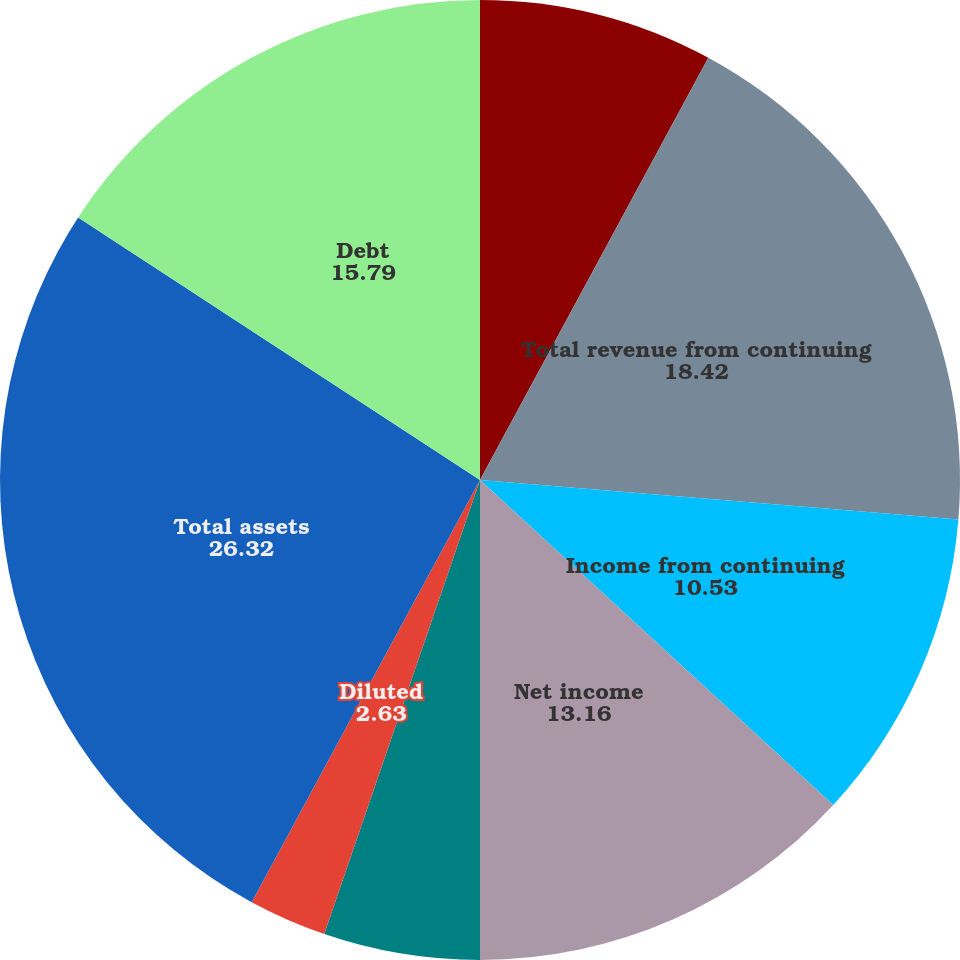<chart> <loc_0><loc_0><loc_500><loc_500><pie_chart><fcel>(thousands except per share<fcel>Total revenue from continuing<fcel>Income from continuing<fcel>Net income<fcel>Basic<fcel>Diluted<fcel>Cash dividends declared per<fcel>Total assets<fcel>Debt<nl><fcel>7.89%<fcel>18.42%<fcel>10.53%<fcel>13.16%<fcel>5.26%<fcel>2.63%<fcel>0.0%<fcel>26.32%<fcel>15.79%<nl></chart> 